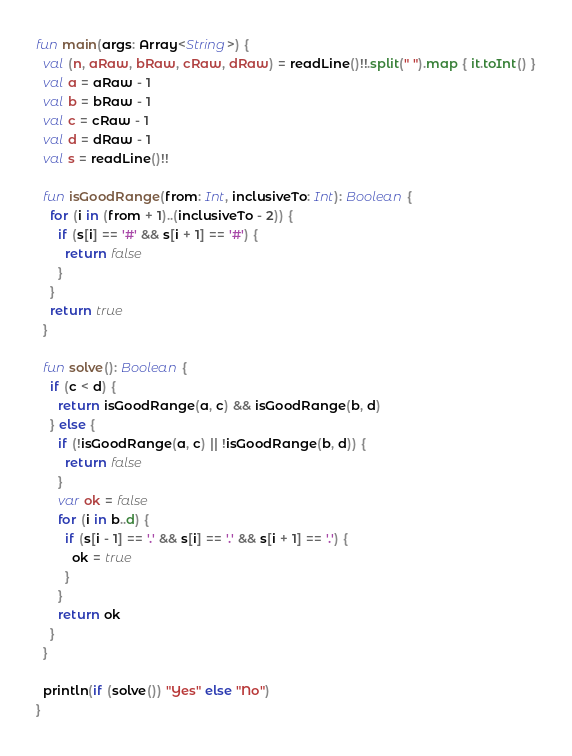<code> <loc_0><loc_0><loc_500><loc_500><_Kotlin_>fun main(args: Array<String>) {
  val (n, aRaw, bRaw, cRaw, dRaw) = readLine()!!.split(" ").map { it.toInt() }
  val a = aRaw - 1
  val b = bRaw - 1
  val c = cRaw - 1
  val d = dRaw - 1
  val s = readLine()!!

  fun isGoodRange(from: Int, inclusiveTo: Int): Boolean {
    for (i in (from + 1)..(inclusiveTo - 2)) {
      if (s[i] == '#' && s[i + 1] == '#') {
        return false
      }
    }
    return true
  }

  fun solve(): Boolean {
    if (c < d) {
      return isGoodRange(a, c) && isGoodRange(b, d)
    } else {
      if (!isGoodRange(a, c) || !isGoodRange(b, d)) {
        return false
      }
      var ok = false
      for (i in b..d) {
        if (s[i - 1] == '.' && s[i] == '.' && s[i + 1] == '.') {
          ok = true
        }
      }
      return ok
    }
  }

  println(if (solve()) "Yes" else "No")
}</code> 